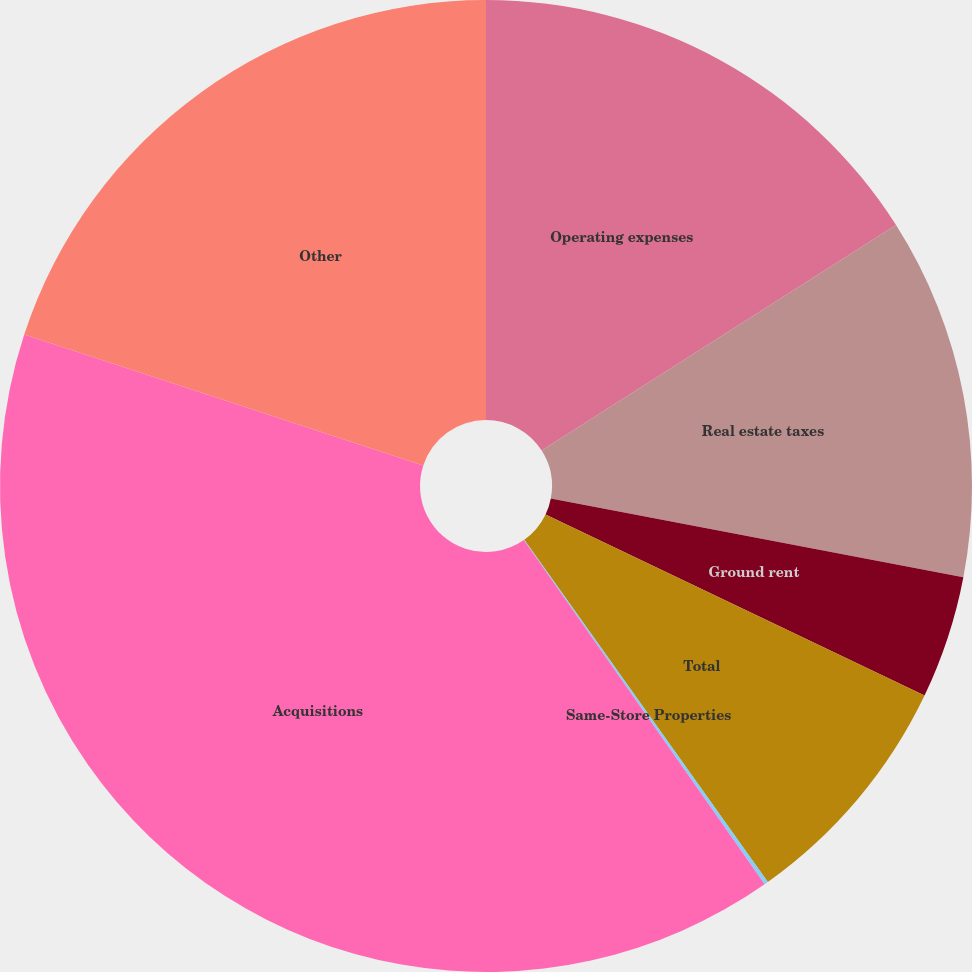Convert chart. <chart><loc_0><loc_0><loc_500><loc_500><pie_chart><fcel>Operating expenses<fcel>Real estate taxes<fcel>Ground rent<fcel>Total<fcel>Same-Store Properties<fcel>Acquisitions<fcel>Other<nl><fcel>15.98%<fcel>12.02%<fcel>4.09%<fcel>8.06%<fcel>0.13%<fcel>39.76%<fcel>19.95%<nl></chart> 